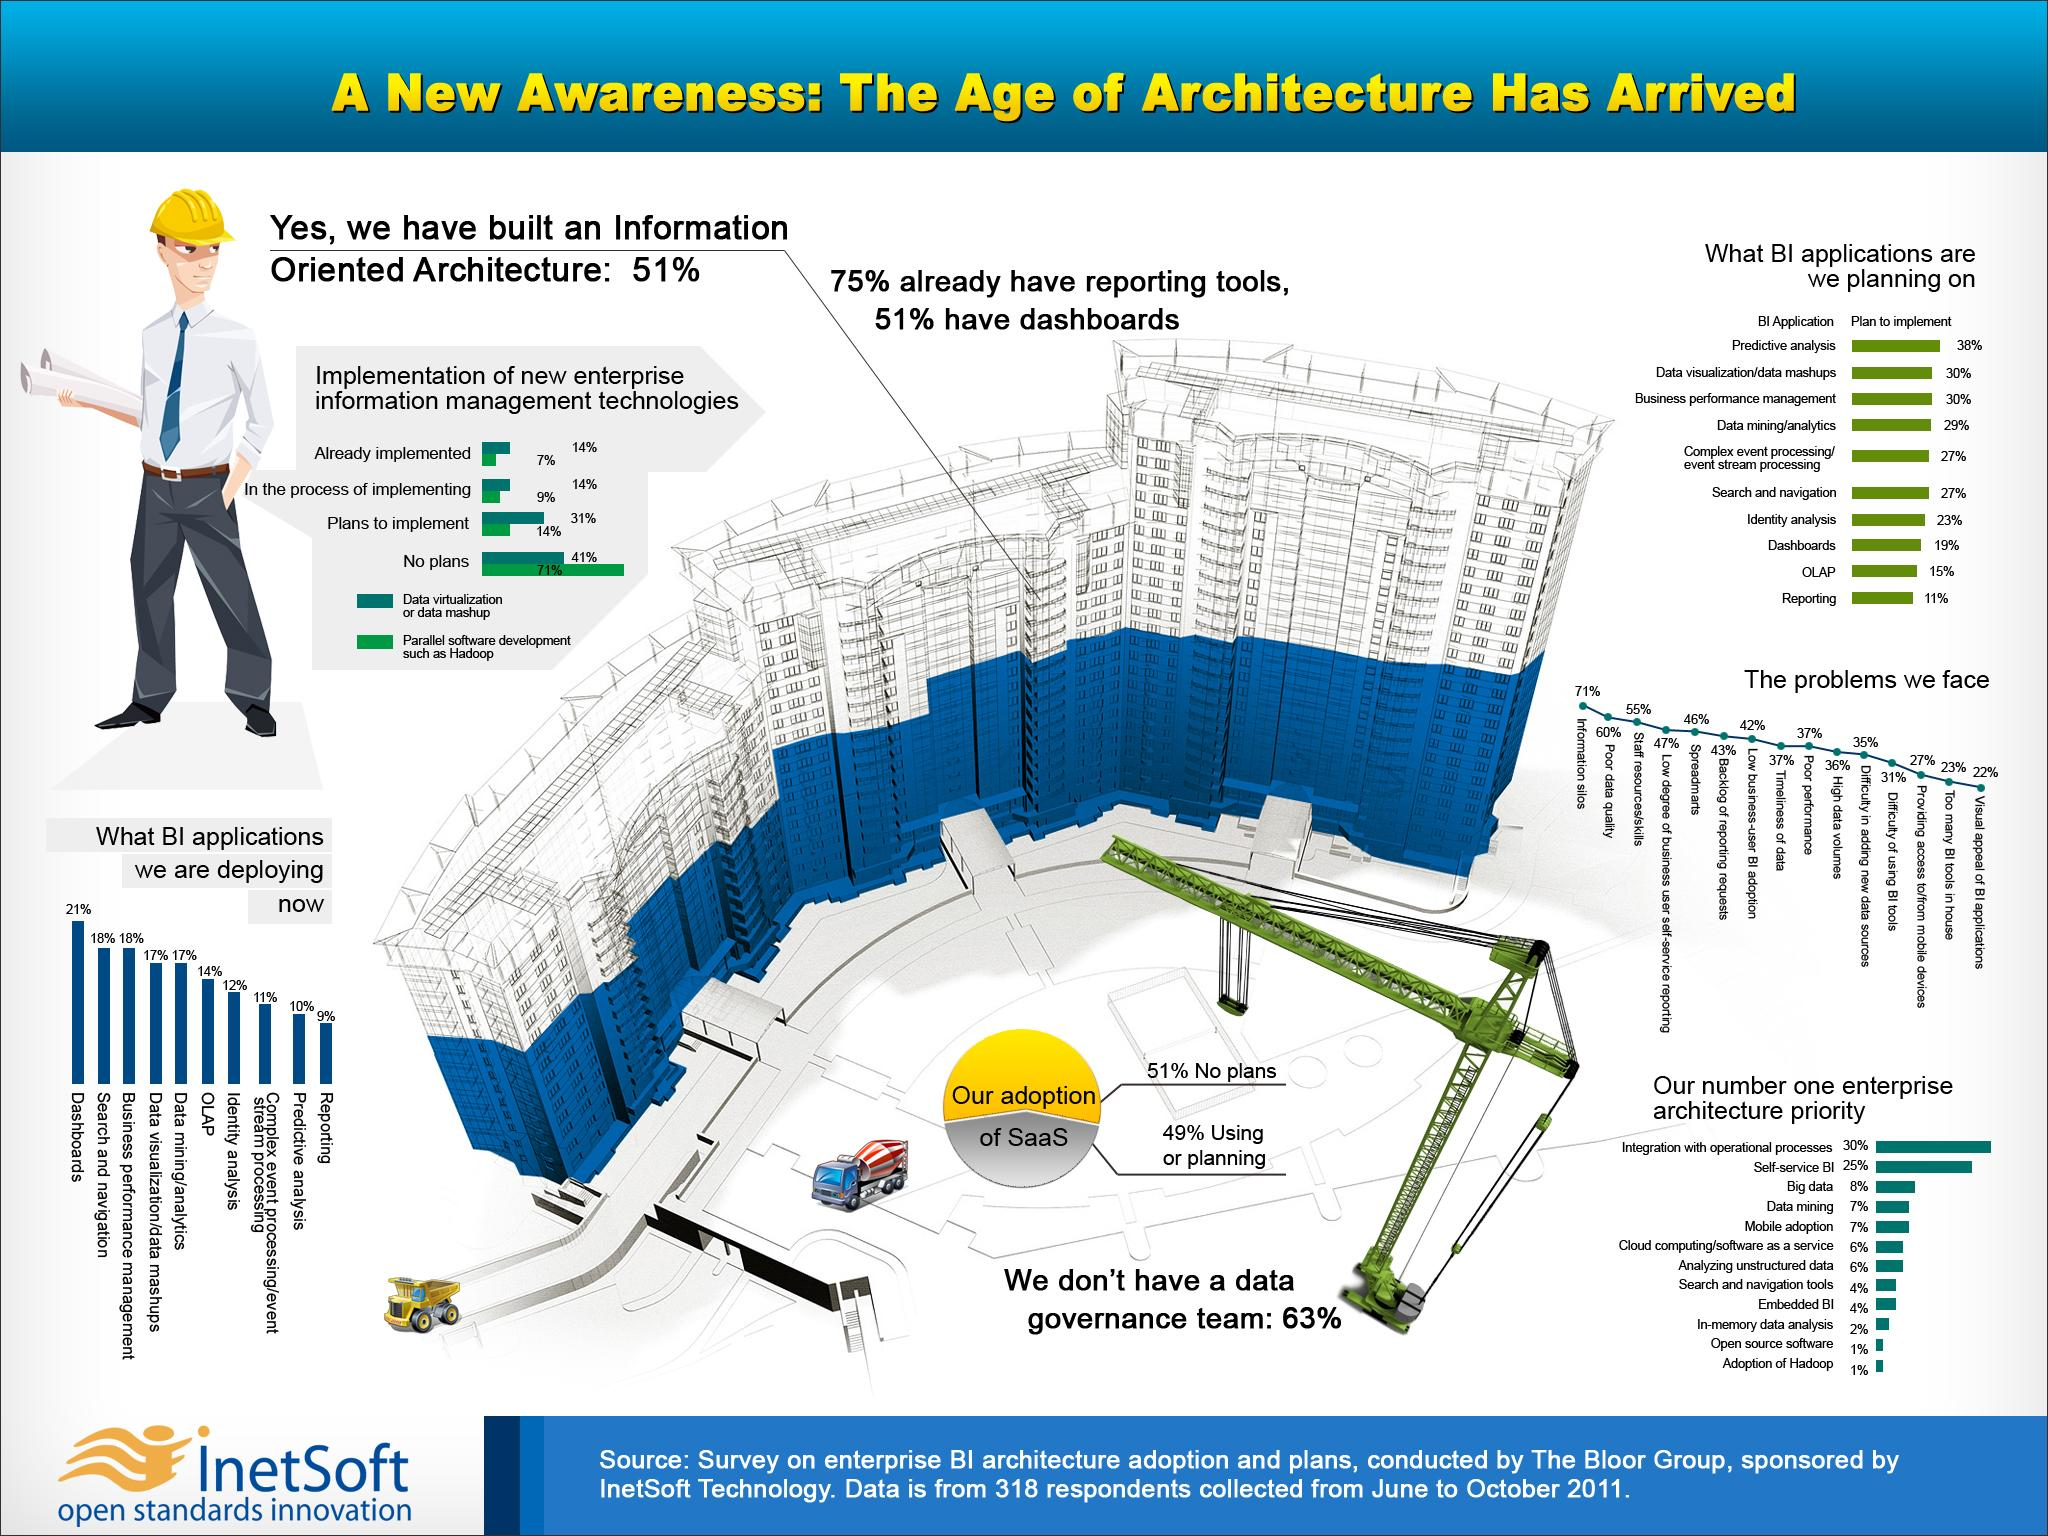Draw attention to some important aspects in this diagram. According to a survey conducted in 2011, 41% of enterprises did not have plans to implement data visualization or mashup. According to a survey conducted in 2011, OLAP (online analytical processing) was found to be the most commonly deployed type of business intelligence (BI) application in 14% of enterprise architectures. According to a survey conducted in 2011, dashboards were the most commonly deployed business intelligence (BI) application in approximately 21% of enterprise architectures. According to a survey conducted in 2011, approximately 9% of enterprises were in the process of implementing parallel software development using Hadoop or similar technologies. The majority of enterprises face a problem in deploying Business Intelligence (BI) applications, as indicated by a survey in 2011, which is the existence of information silos. 